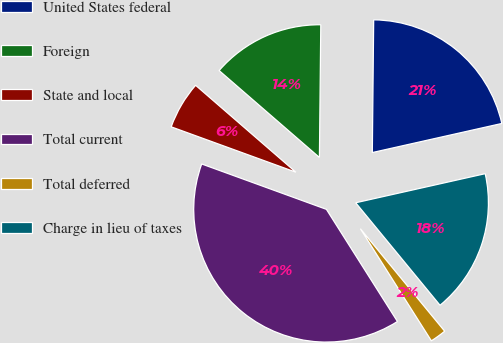<chart> <loc_0><loc_0><loc_500><loc_500><pie_chart><fcel>United States federal<fcel>Foreign<fcel>State and local<fcel>Total current<fcel>Total deferred<fcel>Charge in lieu of taxes<nl><fcel>21.32%<fcel>13.8%<fcel>5.81%<fcel>39.54%<fcel>1.97%<fcel>17.56%<nl></chart> 